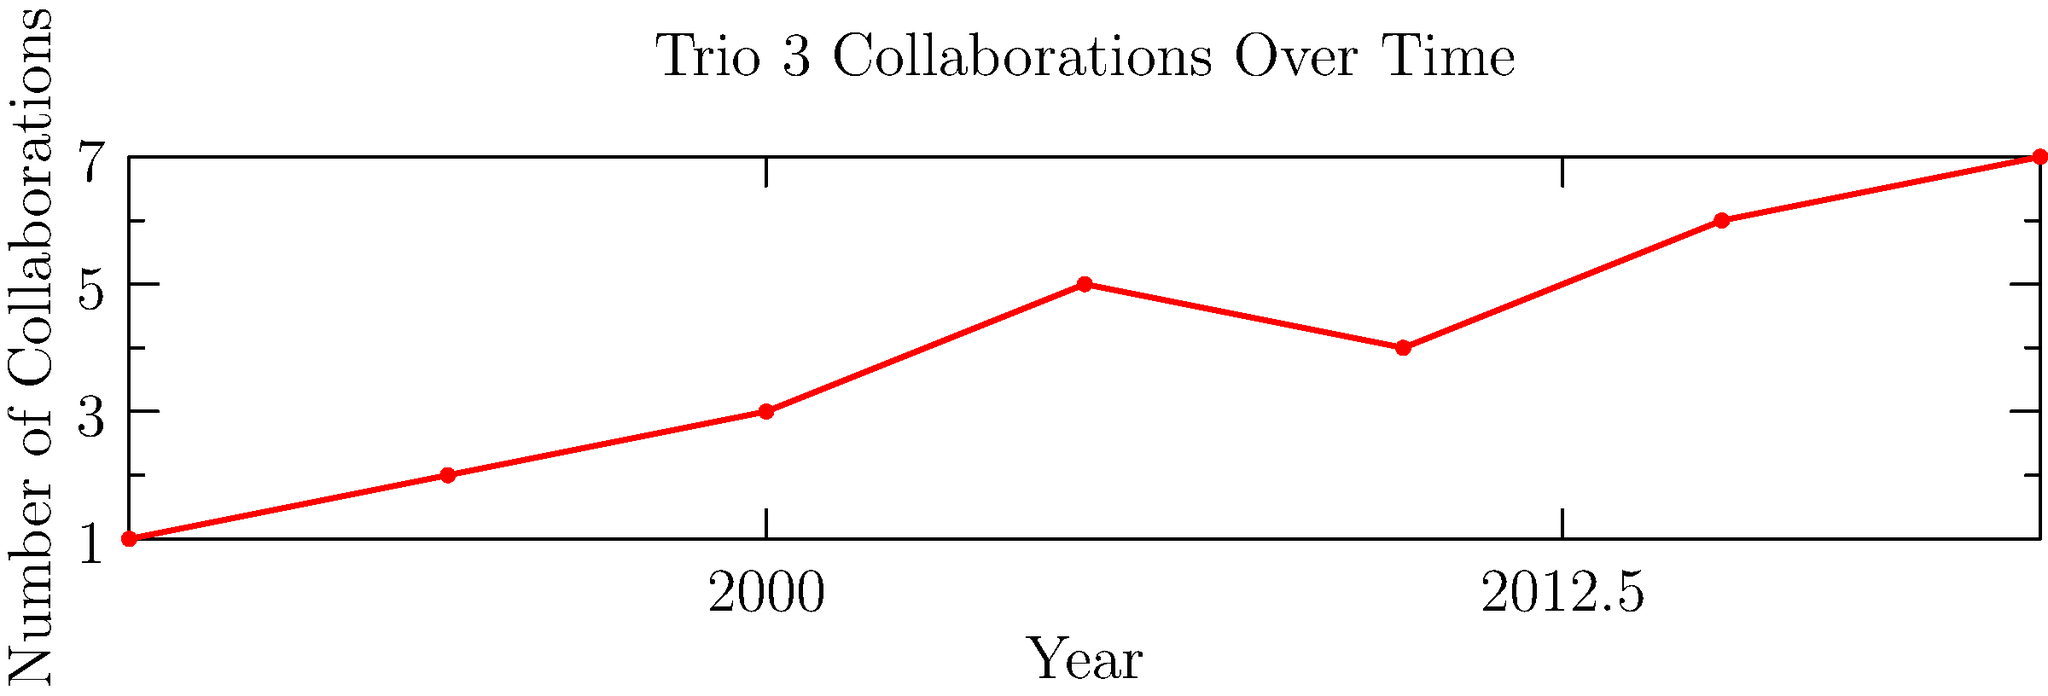Based on the timeline infographic of Trio 3's collaborations, in which year did the group reach its peak number of collaborations with other jazz artists? To determine the year with the highest number of collaborations:

1. Examine the y-axis, which represents the number of collaborations.
2. Scan the graph for the highest point on the red line.
3. The highest point corresponds to 7 collaborations.
4. Trace this point to the x-axis to find the corresponding year.
5. The x-axis shows that this peak occurs in 2020.

Therefore, Trio 3 reached its peak number of collaborations in 2020.
Answer: 2020 